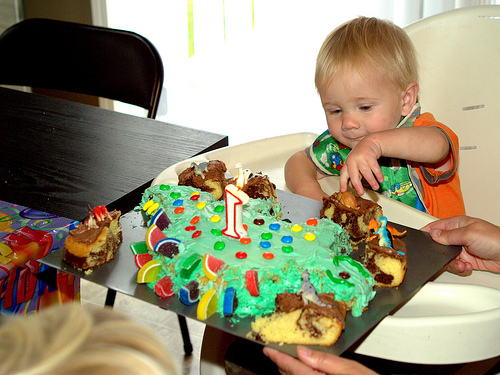<image>
Is the candle in front of the baby? Yes. The candle is positioned in front of the baby, appearing closer to the camera viewpoint. 